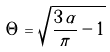<formula> <loc_0><loc_0><loc_500><loc_500>\Theta = \sqrt { \frac { 3 \, \alpha } { \pi } - 1 } \,</formula> 